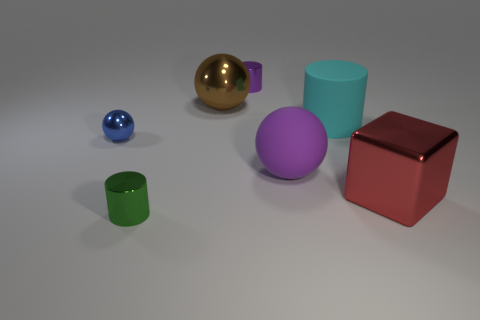Subtract all metallic cylinders. How many cylinders are left? 1 Subtract 1 spheres. How many spheres are left? 2 Add 2 tiny brown metal spheres. How many objects exist? 9 Subtract all yellow balls. Subtract all brown cubes. How many balls are left? 3 Subtract 0 gray cubes. How many objects are left? 7 Subtract all cylinders. How many objects are left? 4 Subtract all big yellow rubber things. Subtract all metal spheres. How many objects are left? 5 Add 1 tiny metal things. How many tiny metal things are left? 4 Add 6 tiny green metal objects. How many tiny green metal objects exist? 7 